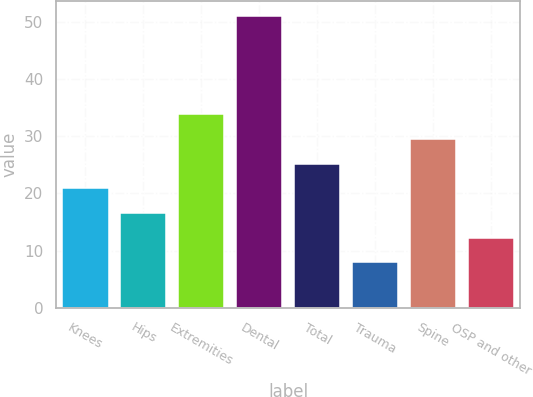<chart> <loc_0><loc_0><loc_500><loc_500><bar_chart><fcel>Knees<fcel>Hips<fcel>Extremities<fcel>Dental<fcel>Total<fcel>Trauma<fcel>Spine<fcel>OSP and other<nl><fcel>20.9<fcel>16.6<fcel>33.8<fcel>51<fcel>25.2<fcel>8<fcel>29.5<fcel>12.3<nl></chart> 